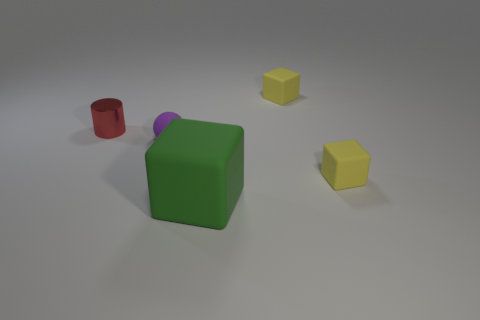Subtract all cyan balls. How many yellow blocks are left? 2 Subtract all tiny cubes. How many cubes are left? 1 Subtract all spheres. How many objects are left? 4 Add 2 small yellow rubber cubes. How many objects exist? 7 Subtract all yellow cubes. How many cubes are left? 1 Subtract all brown cylinders. Subtract all yellow balls. How many cylinders are left? 1 Subtract all large green things. Subtract all cubes. How many objects are left? 1 Add 4 cylinders. How many cylinders are left? 5 Add 3 purple spheres. How many purple spheres exist? 4 Subtract 0 blue cubes. How many objects are left? 5 